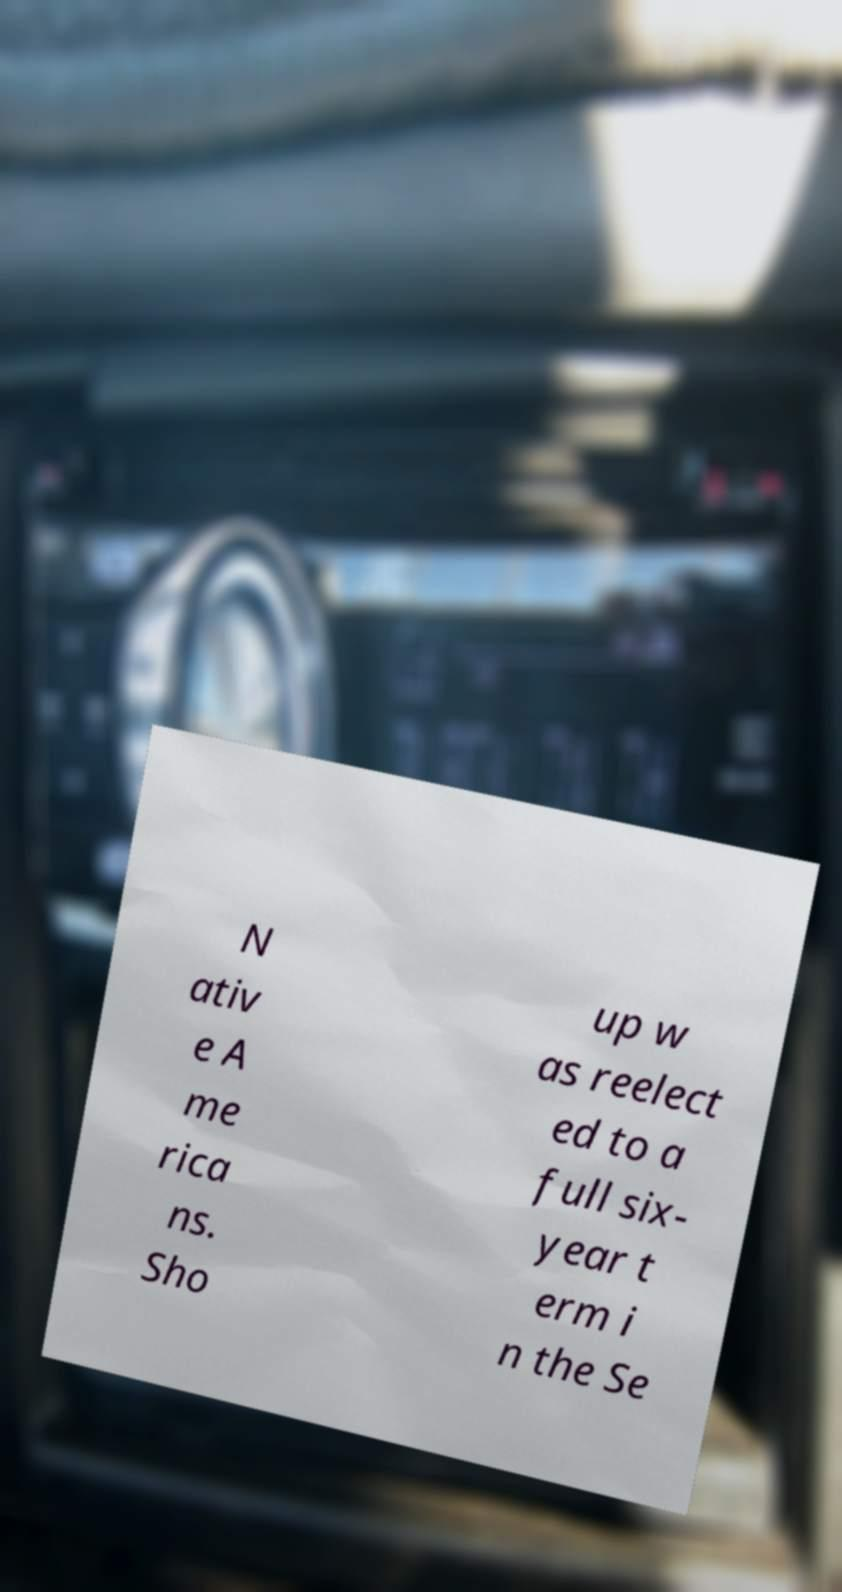Can you read and provide the text displayed in the image?This photo seems to have some interesting text. Can you extract and type it out for me? N ativ e A me rica ns. Sho up w as reelect ed to a full six- year t erm i n the Se 